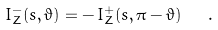<formula> <loc_0><loc_0><loc_500><loc_500>I _ { Z } ^ { - } ( s , \vartheta ) = - \, I _ { Z } ^ { + } ( s , \pi - \vartheta ) \ \ . \</formula> 